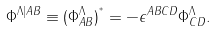Convert formula to latex. <formula><loc_0><loc_0><loc_500><loc_500>\Phi ^ { \Lambda | A B } \equiv ( \Phi _ { A B } ^ { \Lambda } ) ^ { ^ { * } } = - \epsilon ^ { A B C D } \Phi _ { C D } ^ { \Lambda } .</formula> 